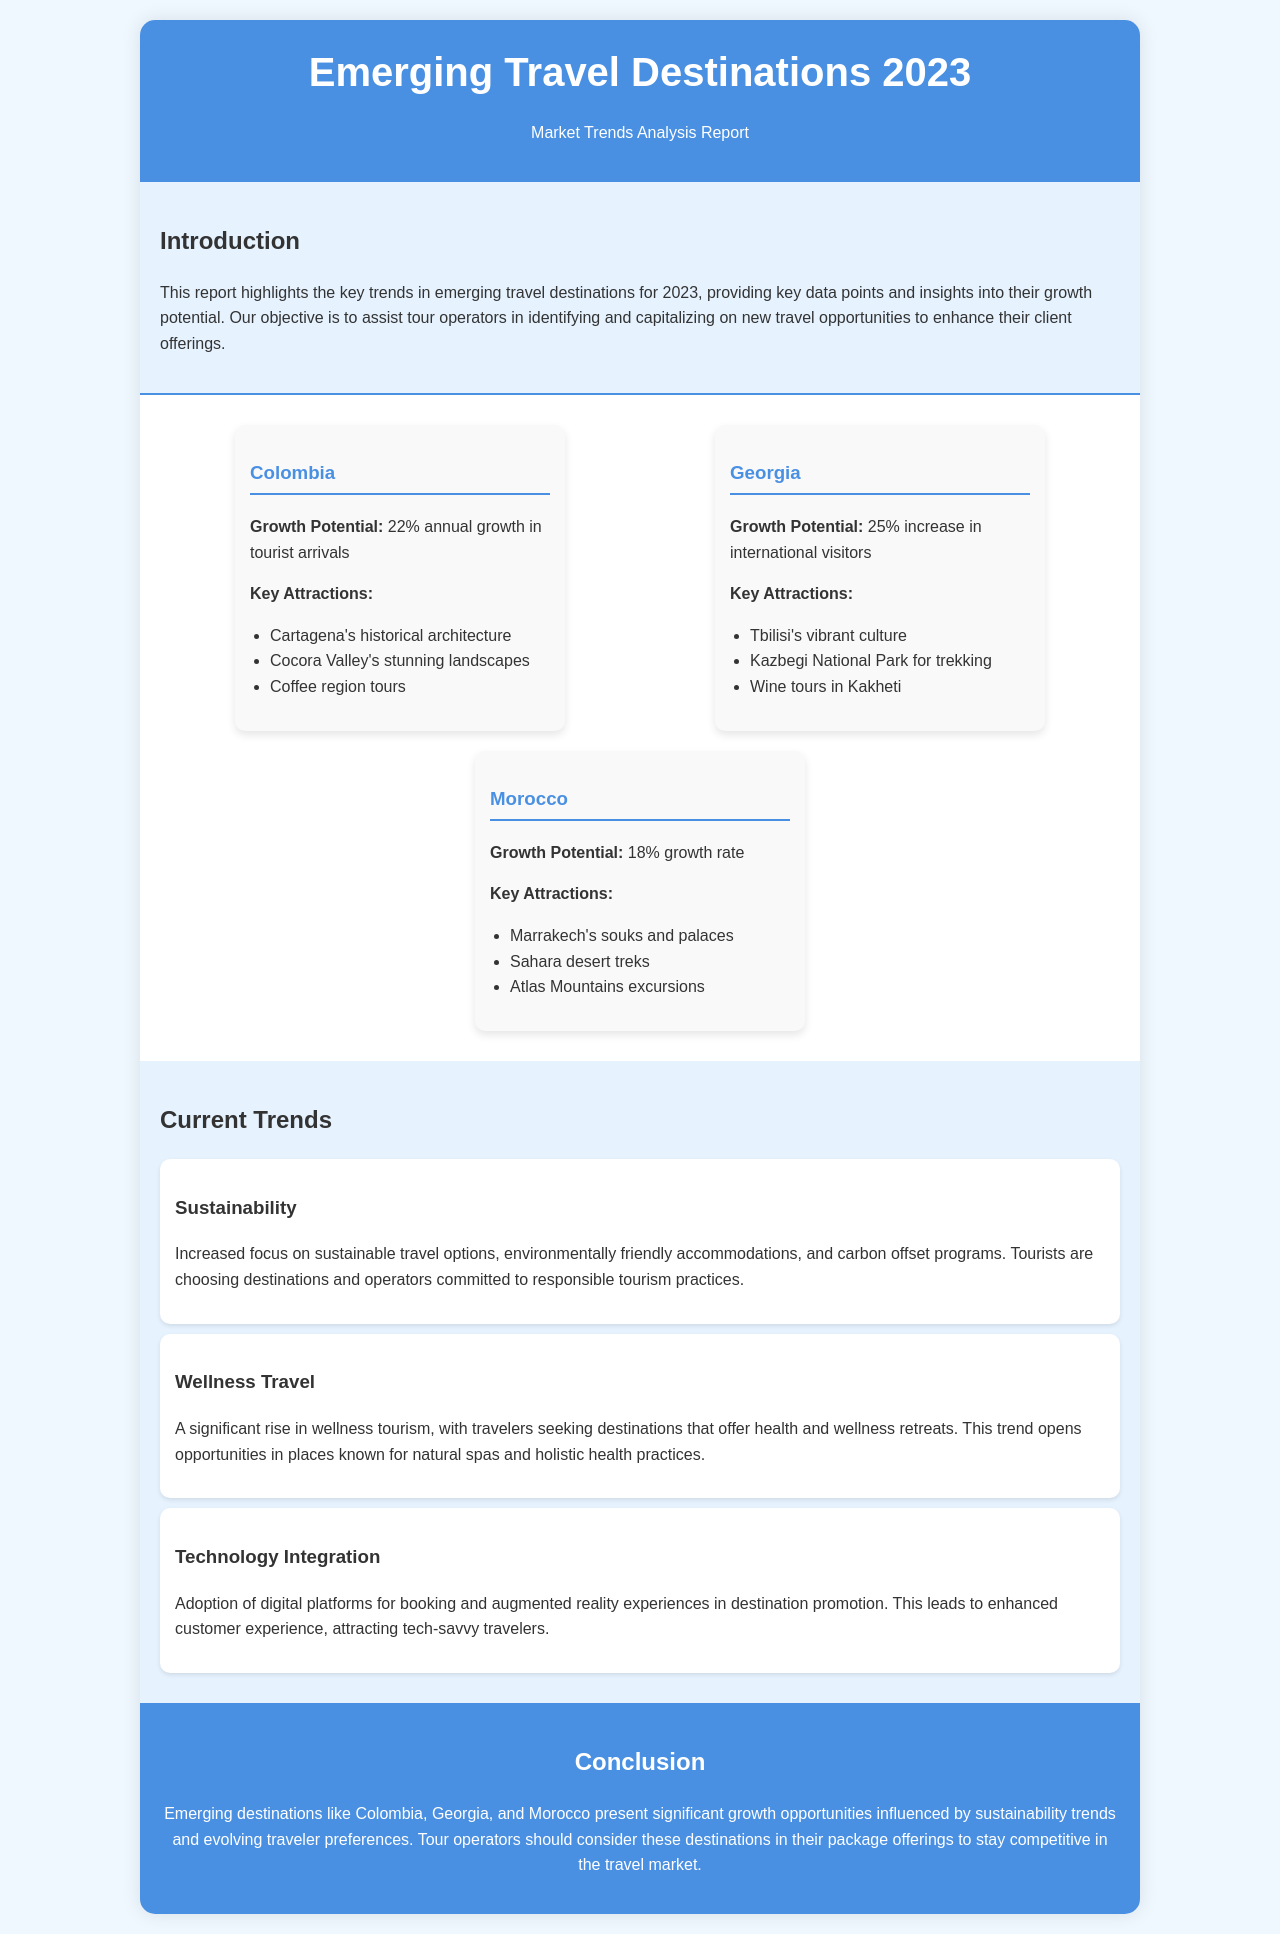What is the annual growth percentage for Colombia? The document states that Colombia has a growth potential of 22% annual growth in tourist arrivals.
Answer: 22% What are the key attractions in Georgia? The document lists Tbilisi's vibrant culture, Kazbegi National Park for trekking, and wine tours in Kakheti as key attractions in Georgia.
Answer: Tbilisi's vibrant culture, Kazbegi National Park for trekking, wine tours in Kakheti What is the growth potential of Morocco? Morocco is reported to have a growth rate of 18%.
Answer: 18% Which travel trend emphasizes environmentally friendly options? The document describes a trend focusing on sustainability, which includes environmentally friendly accommodations and carbon offset programs.
Answer: Sustainability What type of travel is significantly rising according to the report? The report notes a significant rise in wellness tourism, where travelers seek health and wellness retreats.
Answer: Wellness Travel How many destinations are featured in the report? The document highlights three emerging destinations: Colombia, Georgia, and Morocco.
Answer: Three What is the color of the header background? The header background is described as being colored #4a90e2.
Answer: #4a90e2 What should tour operators consider according to the conclusion? The conclusion suggests that tour operators should consider emerging destinations like Colombia, Georgia, and Morocco in their package offerings.
Answer: Emerging destinations like Colombia, Georgia, and Morocco 